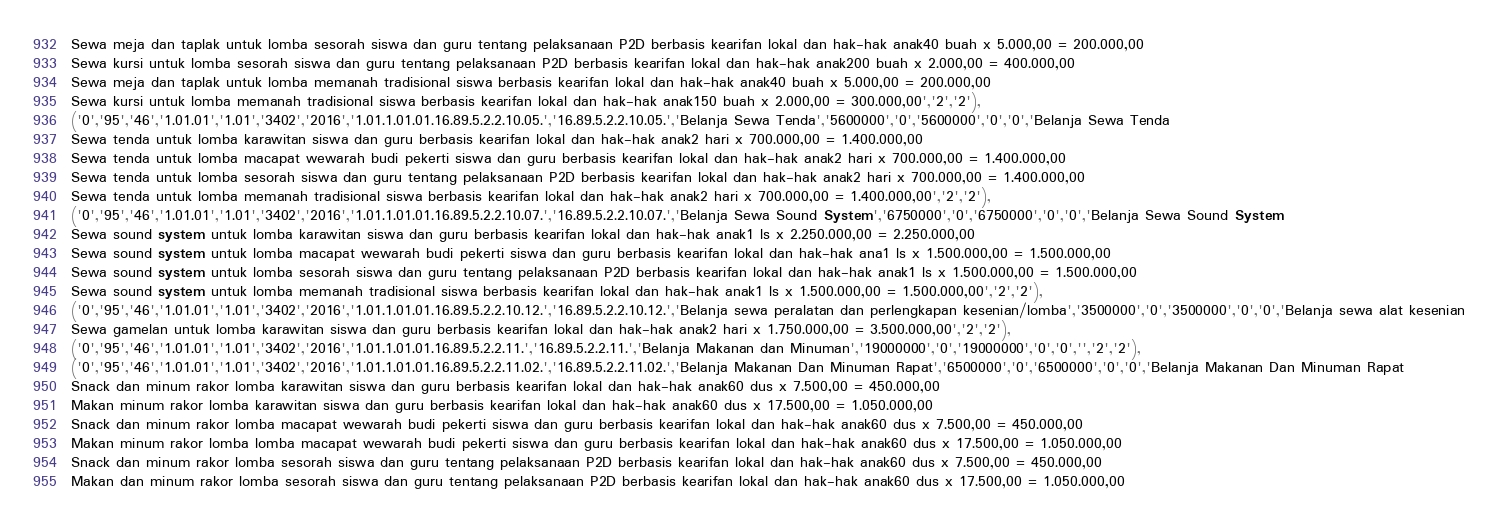Convert code to text. <code><loc_0><loc_0><loc_500><loc_500><_SQL_>Sewa meja dan taplak untuk lomba sesorah siswa dan guru tentang pelaksanaan P2D berbasis kearifan lokal dan hak-hak anak40 buah x 5.000,00 = 200.000,00
Sewa kursi untuk lomba sesorah siswa dan guru tentang pelaksanaan P2D berbasis kearifan lokal dan hak-hak anak200 buah x 2.000,00 = 400.000,00
Sewa meja dan taplak untuk lomba memanah tradisional siswa berbasis kearifan lokal dan hak-hak anak40 buah x 5.000,00 = 200.000,00
Sewa kursi untuk lomba memanah tradisional siswa berbasis kearifan lokal dan hak-hak anak150 buah x 2.000,00 = 300.000,00','2','2'),
('0','95','46','1.01.01','1.01','3402','2016','1.01.1.01.01.16.89.5.2.2.10.05.','16.89.5.2.2.10.05.','Belanja Sewa Tenda','5600000','0','5600000','0','0','Belanja Sewa Tenda
Sewa tenda untuk lomba karawitan siswa dan guru berbasis kearifan lokal dan hak-hak anak2 hari x 700.000,00 = 1.400.000,00
Sewa tenda untuk lomba macapat wewarah budi pekerti siswa dan guru berbasis kearifan lokal dan hak-hak anak2 hari x 700.000,00 = 1.400.000,00
Sewa tenda untuk lomba sesorah siswa dan guru tentang pelaksanaan P2D berbasis kearifan lokal dan hak-hak anak2 hari x 700.000,00 = 1.400.000,00
Sewa tenda untuk lomba memanah tradisional siswa berbasis kearifan lokal dan hak-hak anak2 hari x 700.000,00 = 1.400.000,00','2','2'),
('0','95','46','1.01.01','1.01','3402','2016','1.01.1.01.01.16.89.5.2.2.10.07.','16.89.5.2.2.10.07.','Belanja Sewa Sound System','6750000','0','6750000','0','0','Belanja Sewa Sound System
Sewa sound system untuk lomba karawitan siswa dan guru berbasis kearifan lokal dan hak-hak anak1 ls x 2.250.000,00 = 2.250.000,00
Sewa sound system untuk lomba macapat wewarah budi pekerti siswa dan guru berbasis kearifan lokal dan hak-hak ana1 ls x 1.500.000,00 = 1.500.000,00
Sewa sound system untuk lomba sesorah siswa dan guru tentang pelaksanaan P2D berbasis kearifan lokal dan hak-hak anak1 ls x 1.500.000,00 = 1.500.000,00
Sewa sound system untuk lomba memanah tradisional siswa berbasis kearifan lokal dan hak-hak anak1 ls x 1.500.000,00 = 1.500.000,00','2','2'),
('0','95','46','1.01.01','1.01','3402','2016','1.01.1.01.01.16.89.5.2.2.10.12.','16.89.5.2.2.10.12.','Belanja sewa peralatan dan perlengkapan kesenian/lomba','3500000','0','3500000','0','0','Belanja sewa alat kesenian
Sewa gamelan untuk lomba karawitan siswa dan guru berbasis kearifan lokal dan hak-hak anak2 hari x 1.750.000,00 = 3.500.000,00','2','2'),
('0','95','46','1.01.01','1.01','3402','2016','1.01.1.01.01.16.89.5.2.2.11.','16.89.5.2.2.11.','Belanja Makanan dan Minuman','19000000','0','19000000','0','0','','2','2'),
('0','95','46','1.01.01','1.01','3402','2016','1.01.1.01.01.16.89.5.2.2.11.02.','16.89.5.2.2.11.02.','Belanja Makanan Dan Minuman Rapat','6500000','0','6500000','0','0','Belanja Makanan Dan Minuman Rapat
Snack dan minum rakor lomba karawitan siswa dan guru berbasis kearifan lokal dan hak-hak anak60 dus x 7.500,00 = 450.000,00
Makan minum rakor lomba karawitan siswa dan guru berbasis kearifan lokal dan hak-hak anak60 dus x 17.500,00 = 1.050.000,00
Snack dan minum rakor lomba macapat wewarah budi pekerti siswa dan guru berbasis kearifan lokal dan hak-hak anak60 dus x 7.500,00 = 450.000,00
Makan minum rakor lomba lomba macapat wewarah budi pekerti siswa dan guru berbasis kearifan lokal dan hak-hak anak60 dus x 17.500,00 = 1.050.000,00
Snack dan minum rakor lomba sesorah siswa dan guru tentang pelaksanaan P2D berbasis kearifan lokal dan hak-hak anak60 dus x 7.500,00 = 450.000,00
Makan dan minum rakor lomba sesorah siswa dan guru tentang pelaksanaan P2D berbasis kearifan lokal dan hak-hak anak60 dus x 17.500,00 = 1.050.000,00</code> 